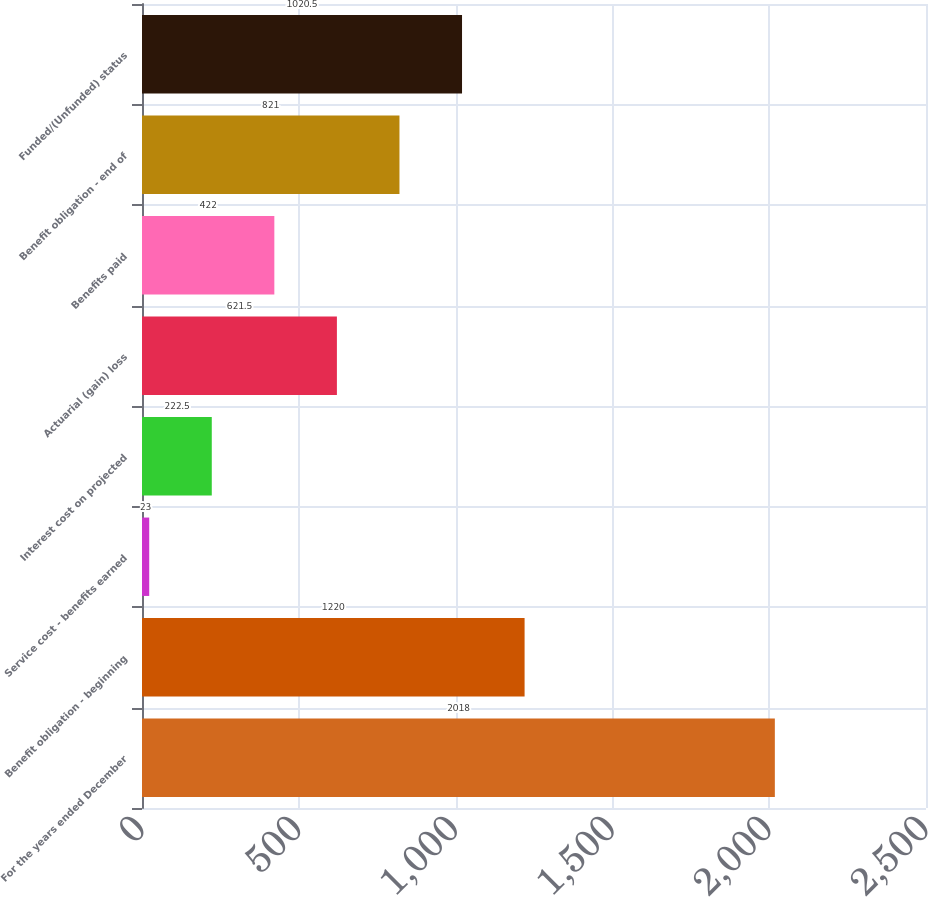<chart> <loc_0><loc_0><loc_500><loc_500><bar_chart><fcel>For the years ended December<fcel>Benefit obligation - beginning<fcel>Service cost - benefits earned<fcel>Interest cost on projected<fcel>Actuarial (gain) loss<fcel>Benefits paid<fcel>Benefit obligation - end of<fcel>Funded/(Unfunded) status<nl><fcel>2018<fcel>1220<fcel>23<fcel>222.5<fcel>621.5<fcel>422<fcel>821<fcel>1020.5<nl></chart> 